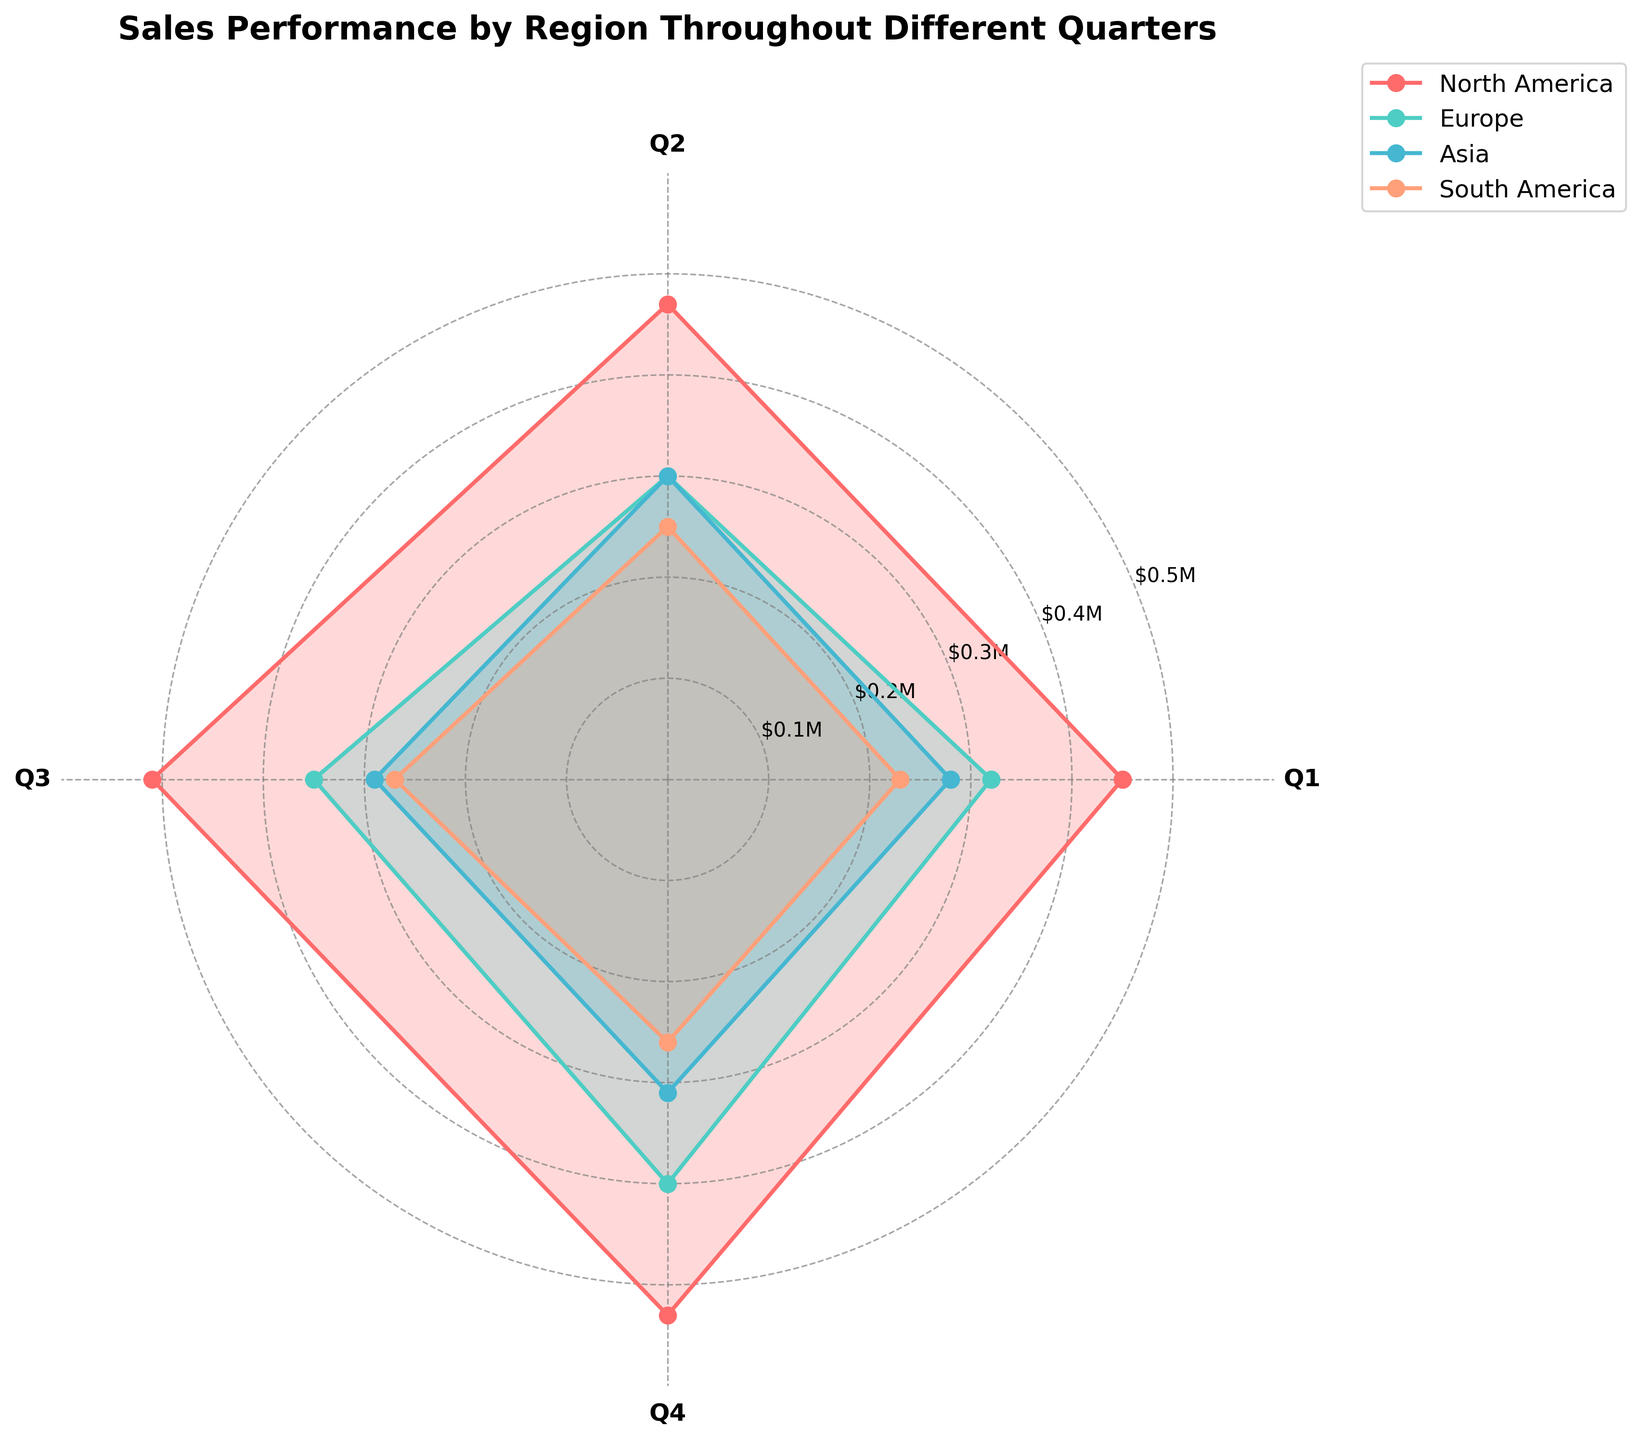What is the title of the polar chart? The title of the chart is usually located at the top and is visually distinct with a larger font size and bold weight.
Answer: Sales Performance by Region Throughout Different Quarters What regions are represented in the polar chart? The legend typically located at the side of the chart lists the regions represented. From the chart, you can see four regions denoted with their respective colors.
Answer: North America, Europe, Asia, South America Which quarter shows the highest sales for North America? North America's sales performance is plotted as a polygon with markers. Identify the point that extends furthest from the center corresponding to each quarter for North America. The highest point is in Q4.
Answer: Q4 How much are the sales for Europe in Q3? Locate the line and marker for Europe and follow it to the Q3 position. The radial distance from the center to the marker represents the sales figure.
Answer: $350,000 What is the total sales for Asia throughout all quarters? To calculate total sales for Asia, sum the individual values for Q1, Q2, Q3, and Q4 visible on the chart. Find the markers for each quarter and add the sales amounts. $280K + $300K + $290K + $310K = $1,180,000
Answer: $1,180,000 Which region has the lowest sales in Q1? Compare the markers for all regions at the Q1 position. The marker closest to the center represents the lowest sales. South America's marker is the nearest to the center.
Answer: South America Are sales for South America higher in Q4 compared to Q1? Compare the markers for South America at Q4 and Q1. The Q4 marker is slightly further from the center than the Q1 marker, indicating higher sales.
Answer: Yes Which quarter has the highest average sales across all regions? Find the sales values for each region by quarter and calculate the average for Q1, Q2, Q3, and Q4. Identify the quarter with the highest average. Sum the sales per quarter: Q1: (450K+320K+280K+230K) = 1,280K, Q2: (470K+300K+300K+250K) = 1,320K, Q3: (510K+350K+290K+270K) = 1,420K, Q4: (530K+400K+310K+260K) = 1,500K. Average: Q1 = 1,280K/4 = 320K, Q2 = 1,320K/4 = 330K, Q3 = 1,420K/4 = 355K, Q4 = 1,500K/4 = 375K. Q4 has the highest average sales.
Answer: Q4 Which region shows the most consistent sales across quarters? Evaluate the relative lengths of the markers for each region. The region with the least variance in the radial distances between its markers is most consistent. Asia's sales markers are the most evenly spaced and consistent.
Answer: Asia Which region has the highest sales in Q3 and what is the value? Find the highest marker in the Q3 position by comparing all regions' markers. The highest marker belongs to North America.
Answer: North America, $510,000 